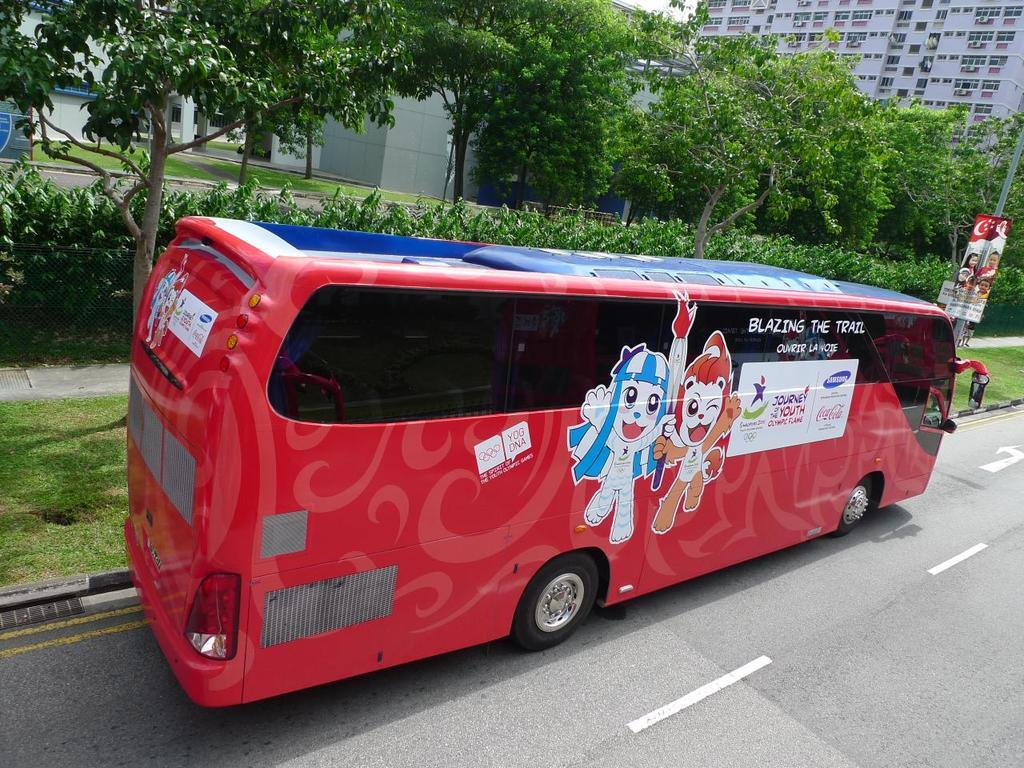What is the main subject in the foreground of the image? There is a red bus in the foreground of the image. What is the bus doing in the image? The bus is moving on the road. What can be seen in the background of the image? There is grass, trees, plants, and buildings in the background of the image. Can you describe the pole on the right side of the image? Yes, there is a pole on the right side of the image. What time of day is the bus shown in the image? The provided facts do not mention the time of day, so it cannot be determined from the image. What type of notebook is the bus driver using in the image? There is no bus driver or notebook present in the image. 